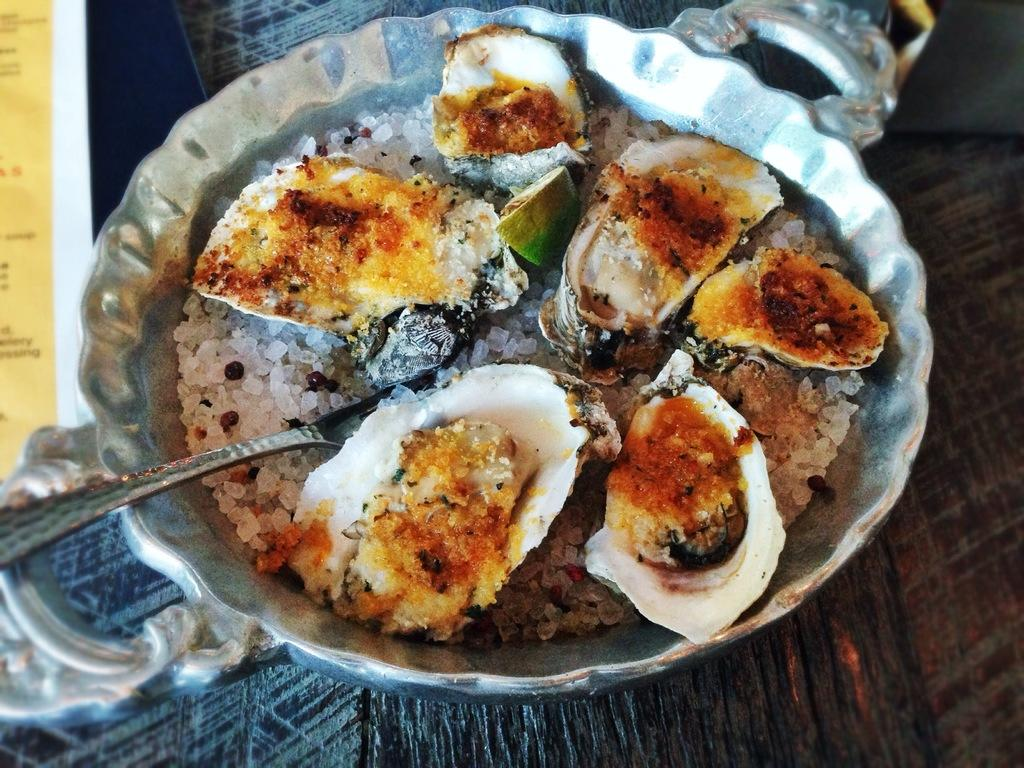What type of container is holding the food in the image? There is a silver-colored vessel holding the food in the image. What utensil is visible in the image? There is a spoon visible in the image. What color is the surface on which the vessel is placed? The vessel is placed on a brown-colored surface. Can you see any loaves of bread floating in the ocean in the image? There is no ocean or loaves of bread present in the image. 